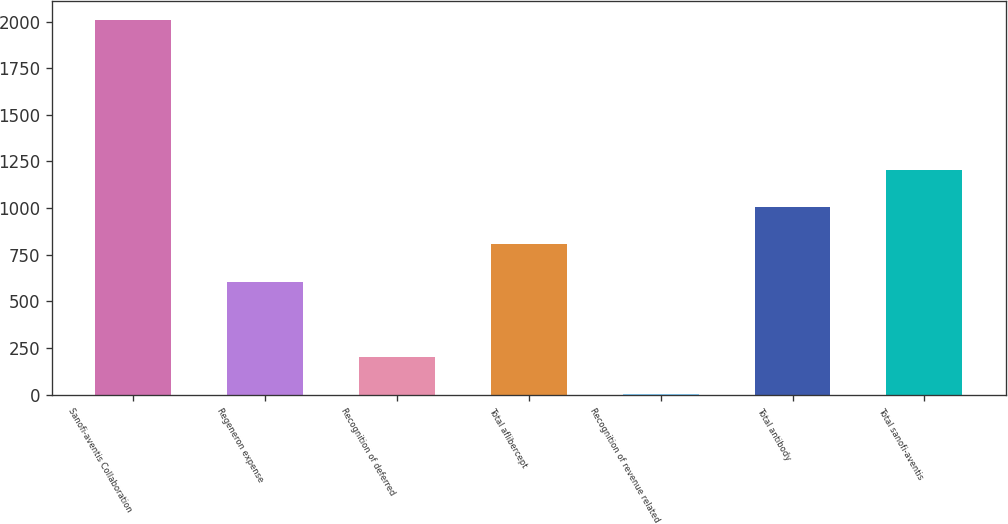Convert chart to OTSL. <chart><loc_0><loc_0><loc_500><loc_500><bar_chart><fcel>Sanofi-aventis Collaboration<fcel>Regeneron expense<fcel>Recognition of deferred<fcel>Total aflibercept<fcel>Recognition of revenue related<fcel>Total antibody<fcel>Total sanofi-aventis<nl><fcel>2010<fcel>604.12<fcel>202.44<fcel>804.96<fcel>1.6<fcel>1005.8<fcel>1206.64<nl></chart> 